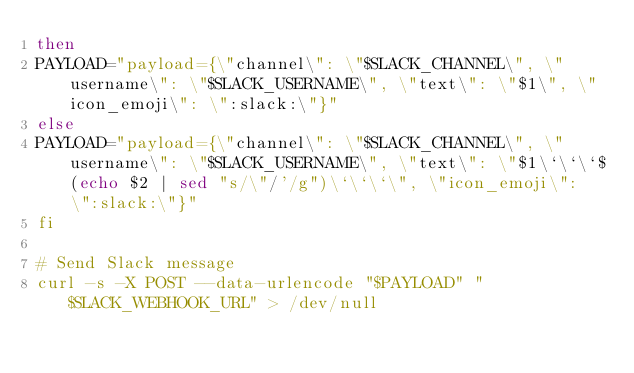Convert code to text. <code><loc_0><loc_0><loc_500><loc_500><_Bash_>then
PAYLOAD="payload={\"channel\": \"$SLACK_CHANNEL\", \"username\": \"$SLACK_USERNAME\", \"text\": \"$1\", \"icon_emoji\": \":slack:\"}"
else
PAYLOAD="payload={\"channel\": \"$SLACK_CHANNEL\", \"username\": \"$SLACK_USERNAME\", \"text\": \"$1\`\`\`$(echo $2 | sed "s/\"/'/g")\`\`\`\", \"icon_emoji\": \":slack:\"}"
fi

# Send Slack message
curl -s -X POST --data-urlencode "$PAYLOAD" "$SLACK_WEBHOOK_URL" > /dev/null</code> 